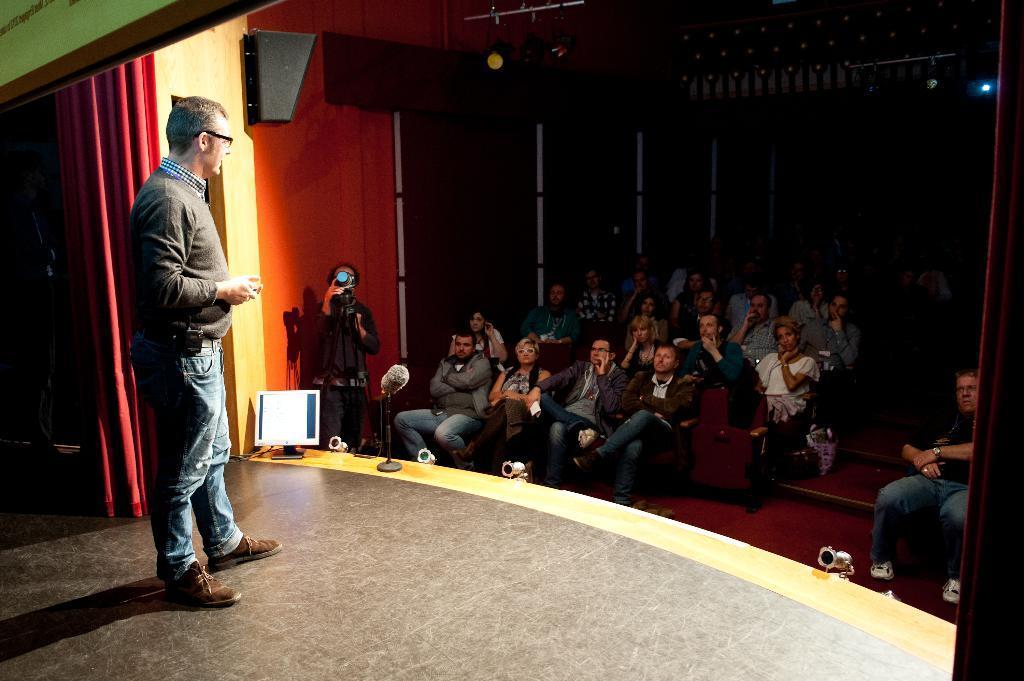Describe this image in one or two sentences. This picture is taken on the stage. On the stage, there is a person wearing a grey jacket, blue jeans and he is holding something. Before him, there are people sitting on the chairs. In the center, there is a man holding a camera. Towards the left, there is a curtain which is in red in color. 